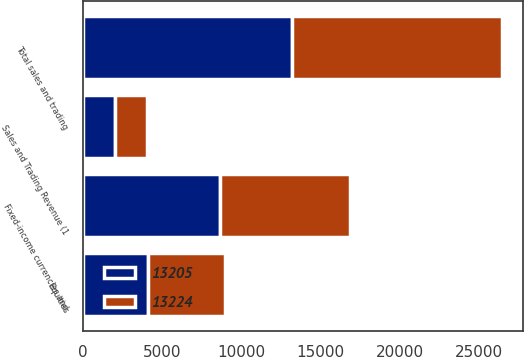Convert chart to OTSL. <chart><loc_0><loc_0><loc_500><loc_500><stacked_bar_chart><ecel><fcel>Sales and Trading Revenue (1<fcel>Fixed-income currencies and<fcel>Equities<fcel>Total sales and trading<nl><fcel>13224<fcel>2018<fcel>8186<fcel>4876<fcel>13224<nl><fcel>13205<fcel>2017<fcel>8657<fcel>4120<fcel>13205<nl></chart> 